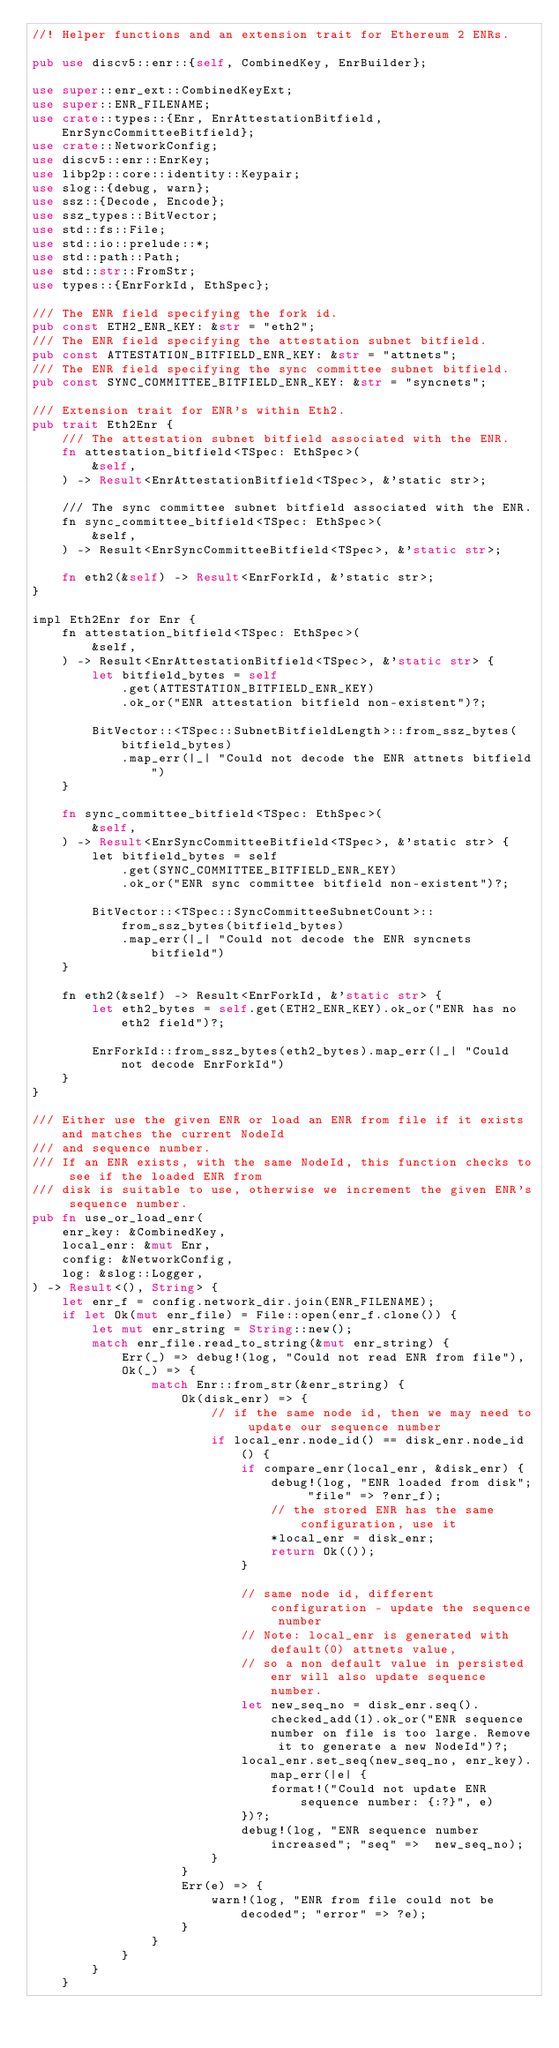<code> <loc_0><loc_0><loc_500><loc_500><_Rust_>//! Helper functions and an extension trait for Ethereum 2 ENRs.

pub use discv5::enr::{self, CombinedKey, EnrBuilder};

use super::enr_ext::CombinedKeyExt;
use super::ENR_FILENAME;
use crate::types::{Enr, EnrAttestationBitfield, EnrSyncCommitteeBitfield};
use crate::NetworkConfig;
use discv5::enr::EnrKey;
use libp2p::core::identity::Keypair;
use slog::{debug, warn};
use ssz::{Decode, Encode};
use ssz_types::BitVector;
use std::fs::File;
use std::io::prelude::*;
use std::path::Path;
use std::str::FromStr;
use types::{EnrForkId, EthSpec};

/// The ENR field specifying the fork id.
pub const ETH2_ENR_KEY: &str = "eth2";
/// The ENR field specifying the attestation subnet bitfield.
pub const ATTESTATION_BITFIELD_ENR_KEY: &str = "attnets";
/// The ENR field specifying the sync committee subnet bitfield.
pub const SYNC_COMMITTEE_BITFIELD_ENR_KEY: &str = "syncnets";

/// Extension trait for ENR's within Eth2.
pub trait Eth2Enr {
    /// The attestation subnet bitfield associated with the ENR.
    fn attestation_bitfield<TSpec: EthSpec>(
        &self,
    ) -> Result<EnrAttestationBitfield<TSpec>, &'static str>;

    /// The sync committee subnet bitfield associated with the ENR.
    fn sync_committee_bitfield<TSpec: EthSpec>(
        &self,
    ) -> Result<EnrSyncCommitteeBitfield<TSpec>, &'static str>;

    fn eth2(&self) -> Result<EnrForkId, &'static str>;
}

impl Eth2Enr for Enr {
    fn attestation_bitfield<TSpec: EthSpec>(
        &self,
    ) -> Result<EnrAttestationBitfield<TSpec>, &'static str> {
        let bitfield_bytes = self
            .get(ATTESTATION_BITFIELD_ENR_KEY)
            .ok_or("ENR attestation bitfield non-existent")?;

        BitVector::<TSpec::SubnetBitfieldLength>::from_ssz_bytes(bitfield_bytes)
            .map_err(|_| "Could not decode the ENR attnets bitfield")
    }

    fn sync_committee_bitfield<TSpec: EthSpec>(
        &self,
    ) -> Result<EnrSyncCommitteeBitfield<TSpec>, &'static str> {
        let bitfield_bytes = self
            .get(SYNC_COMMITTEE_BITFIELD_ENR_KEY)
            .ok_or("ENR sync committee bitfield non-existent")?;

        BitVector::<TSpec::SyncCommitteeSubnetCount>::from_ssz_bytes(bitfield_bytes)
            .map_err(|_| "Could not decode the ENR syncnets bitfield")
    }

    fn eth2(&self) -> Result<EnrForkId, &'static str> {
        let eth2_bytes = self.get(ETH2_ENR_KEY).ok_or("ENR has no eth2 field")?;

        EnrForkId::from_ssz_bytes(eth2_bytes).map_err(|_| "Could not decode EnrForkId")
    }
}

/// Either use the given ENR or load an ENR from file if it exists and matches the current NodeId
/// and sequence number.
/// If an ENR exists, with the same NodeId, this function checks to see if the loaded ENR from
/// disk is suitable to use, otherwise we increment the given ENR's sequence number.
pub fn use_or_load_enr(
    enr_key: &CombinedKey,
    local_enr: &mut Enr,
    config: &NetworkConfig,
    log: &slog::Logger,
) -> Result<(), String> {
    let enr_f = config.network_dir.join(ENR_FILENAME);
    if let Ok(mut enr_file) = File::open(enr_f.clone()) {
        let mut enr_string = String::new();
        match enr_file.read_to_string(&mut enr_string) {
            Err(_) => debug!(log, "Could not read ENR from file"),
            Ok(_) => {
                match Enr::from_str(&enr_string) {
                    Ok(disk_enr) => {
                        // if the same node id, then we may need to update our sequence number
                        if local_enr.node_id() == disk_enr.node_id() {
                            if compare_enr(local_enr, &disk_enr) {
                                debug!(log, "ENR loaded from disk"; "file" => ?enr_f);
                                // the stored ENR has the same configuration, use it
                                *local_enr = disk_enr;
                                return Ok(());
                            }

                            // same node id, different configuration - update the sequence number
                            // Note: local_enr is generated with default(0) attnets value,
                            // so a non default value in persisted enr will also update sequence number.
                            let new_seq_no = disk_enr.seq().checked_add(1).ok_or("ENR sequence number on file is too large. Remove it to generate a new NodeId")?;
                            local_enr.set_seq(new_seq_no, enr_key).map_err(|e| {
                                format!("Could not update ENR sequence number: {:?}", e)
                            })?;
                            debug!(log, "ENR sequence number increased"; "seq" =>  new_seq_no);
                        }
                    }
                    Err(e) => {
                        warn!(log, "ENR from file could not be decoded"; "error" => ?e);
                    }
                }
            }
        }
    }
</code> 